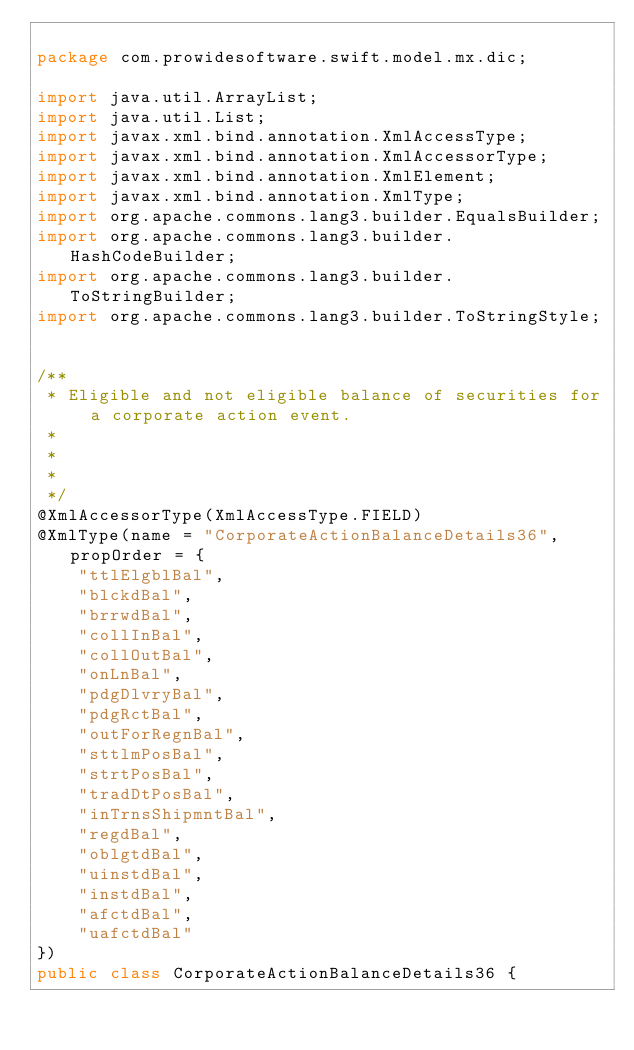<code> <loc_0><loc_0><loc_500><loc_500><_Java_>
package com.prowidesoftware.swift.model.mx.dic;

import java.util.ArrayList;
import java.util.List;
import javax.xml.bind.annotation.XmlAccessType;
import javax.xml.bind.annotation.XmlAccessorType;
import javax.xml.bind.annotation.XmlElement;
import javax.xml.bind.annotation.XmlType;
import org.apache.commons.lang3.builder.EqualsBuilder;
import org.apache.commons.lang3.builder.HashCodeBuilder;
import org.apache.commons.lang3.builder.ToStringBuilder;
import org.apache.commons.lang3.builder.ToStringStyle;


/**
 * Eligible and not eligible balance of securities for a corporate action event.
 * 
 * 
 * 
 */
@XmlAccessorType(XmlAccessType.FIELD)
@XmlType(name = "CorporateActionBalanceDetails36", propOrder = {
    "ttlElgblBal",
    "blckdBal",
    "brrwdBal",
    "collInBal",
    "collOutBal",
    "onLnBal",
    "pdgDlvryBal",
    "pdgRctBal",
    "outForRegnBal",
    "sttlmPosBal",
    "strtPosBal",
    "tradDtPosBal",
    "inTrnsShipmntBal",
    "regdBal",
    "oblgtdBal",
    "uinstdBal",
    "instdBal",
    "afctdBal",
    "uafctdBal"
})
public class CorporateActionBalanceDetails36 {
</code> 